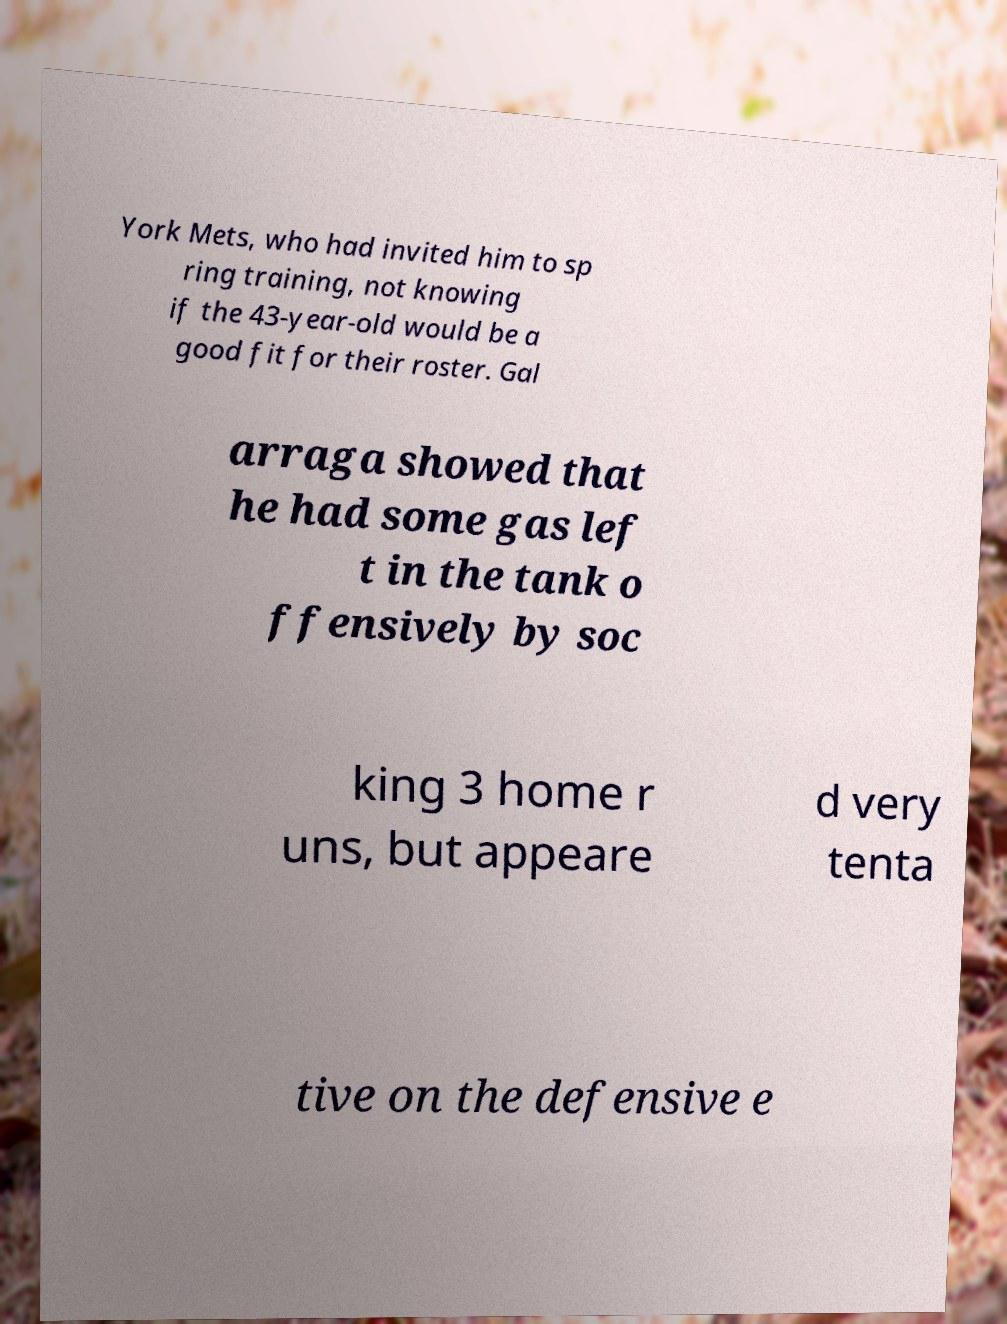Please read and relay the text visible in this image. What does it say? York Mets, who had invited him to sp ring training, not knowing if the 43-year-old would be a good fit for their roster. Gal arraga showed that he had some gas lef t in the tank o ffensively by soc king 3 home r uns, but appeare d very tenta tive on the defensive e 